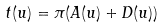Convert formula to latex. <formula><loc_0><loc_0><loc_500><loc_500>t ( u ) = \pi ( A ( u ) + D ( u ) )</formula> 